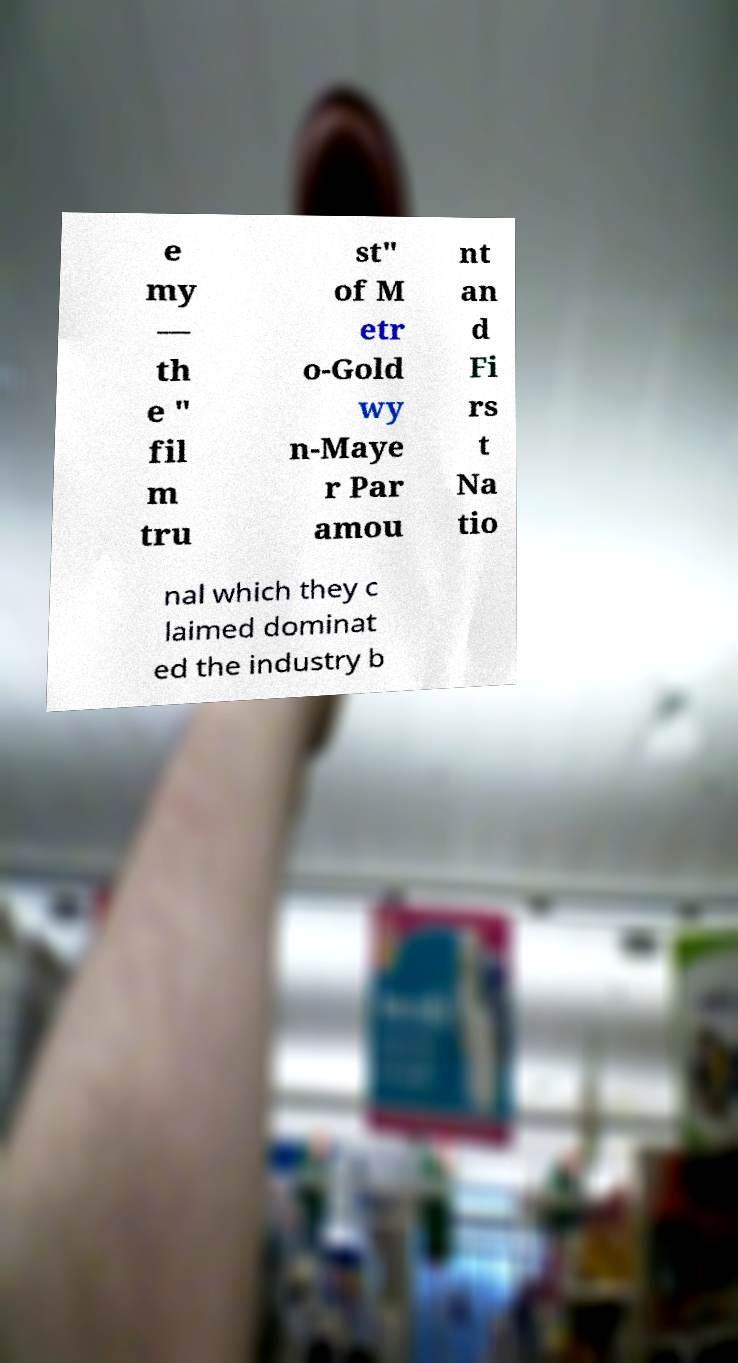Please read and relay the text visible in this image. What does it say? e my — th e " fil m tru st" of M etr o-Gold wy n-Maye r Par amou nt an d Fi rs t Na tio nal which they c laimed dominat ed the industry b 